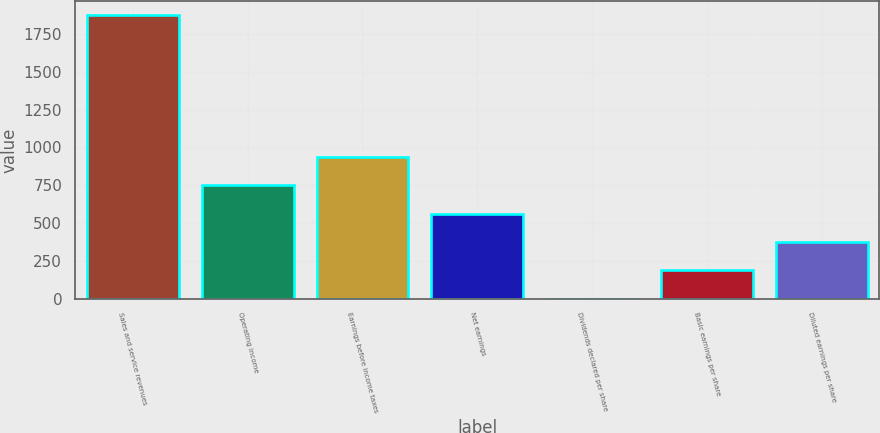Convert chart to OTSL. <chart><loc_0><loc_0><loc_500><loc_500><bar_chart><fcel>Sales and service revenues<fcel>Operating income<fcel>Earnings before income taxes<fcel>Net earnings<fcel>Dividends declared per share<fcel>Basic earnings per share<fcel>Diluted earnings per share<nl><fcel>1874<fcel>750.04<fcel>937.37<fcel>562.71<fcel>0.72<fcel>188.05<fcel>375.38<nl></chart> 